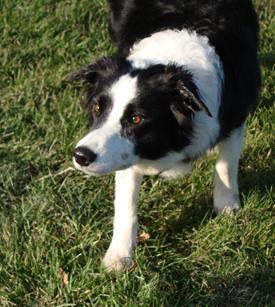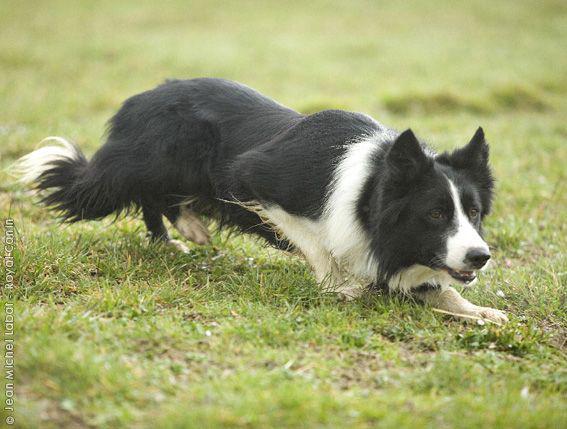The first image is the image on the left, the second image is the image on the right. Analyze the images presented: Is the assertion "The right image shows a border collie hunched near the ground and facing right." valid? Answer yes or no. Yes. 